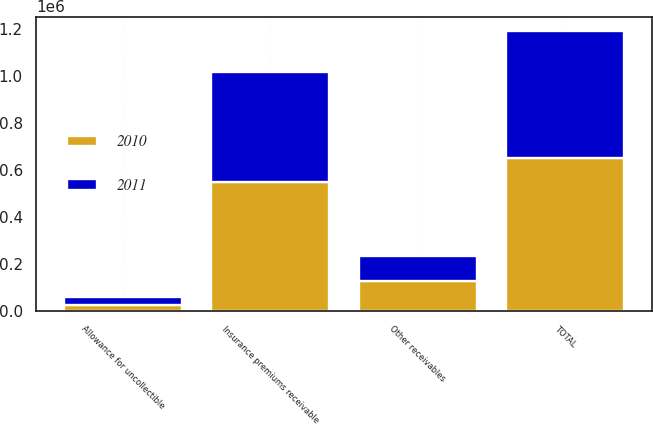<chart> <loc_0><loc_0><loc_500><loc_500><stacked_bar_chart><ecel><fcel>Insurance premiums receivable<fcel>Other receivables<fcel>Allowance for uncollectible<fcel>TOTAL<nl><fcel>2010<fcel>549301<fcel>127528<fcel>27707<fcel>649122<nl><fcel>2011<fcel>468334<fcel>107721<fcel>33128<fcel>542927<nl></chart> 